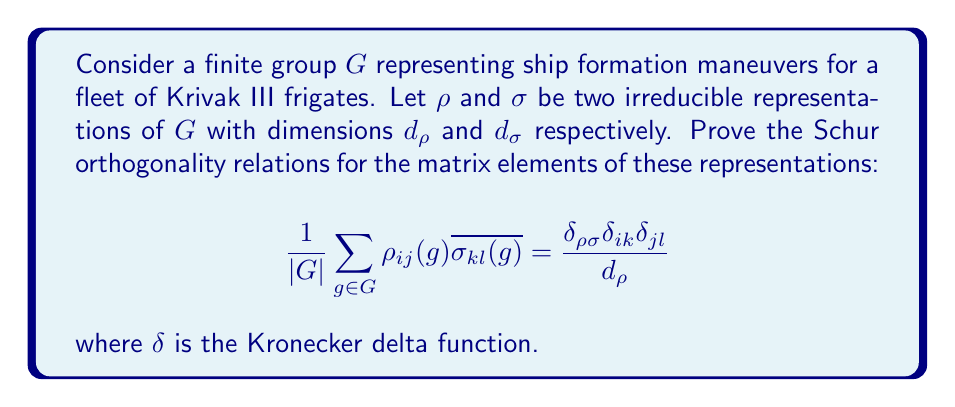Show me your answer to this math problem. To prove the Schur orthogonality relations, we'll follow these steps:

1) First, recall that for irreducible representations, Schur's lemma states that any intertwining operator between them is either zero (if the representations are inequivalent) or a scalar multiple of the identity (if they are equivalent).

2) Define the linear map $T: V_\sigma \to V_\rho$ as:

   $$T = \frac{1}{|G|} \sum_{g \in G} \rho(g) A \sigma(g^{-1})$$

   where $A$ is any linear map from $V_\sigma$ to $V_\rho$.

3) Show that $T$ is an intertwining operator:

   $$\begin{align*}
   \rho(h)T &= \frac{1}{|G|} \sum_{g \in G} \rho(h)\rho(g) A \sigma(g^{-1}) \\
   &= \frac{1}{|G|} \sum_{g \in G} \rho(hg) A \sigma(g^{-1}) \\
   &= \frac{1}{|G|} \sum_{g' \in G} \rho(g') A \sigma((h^{-1}g')^{-1}) \\
   &= \frac{1}{|G|} \sum_{g' \in G} \rho(g') A \sigma(g'^{-1})\sigma(h) \\
   &= T\sigma(h)
   \end{align*}$$

4) By Schur's lemma, $T$ must be zero if $\rho$ and $\sigma$ are inequivalent, or a scalar multiple of the identity if they are equivalent.

5) Choose $A = E_{kl}$, the matrix with 1 in the $(k,l)$ position and 0 elsewhere. Then the $(i,j)$ element of $T$ is:

   $$T_{ij} = \frac{1}{|G|} \sum_{g \in G} \rho_{ij}(g) \overline{\sigma_{kl}(g)}$$

6) If $\rho$ and $\sigma$ are inequivalent, $T = 0$, so $T_{ij} = 0$ for all $i,j$.

7) If $\rho = \sigma$, then $T = cI$ for some scalar $c$. Taking the trace of both sides:

   $$\text{tr}(T) = \frac{1}{|G|} \sum_{g \in G} \text{tr}(\rho(g)E_{kl}) = c d_\rho$$

   The left side simplifies to $\frac{1}{|G|} \sum_{g \in G} \rho_{lk}(g) = \delta_{lk}$

   Therefore, $c = \frac{\delta_{lk}}{d_\rho}$

8) Combining these results gives us the Schur orthogonality relations:

   $$\frac{1}{|G|} \sum_{g \in G} \rho_{ij}(g) \overline{\sigma_{kl}(g)} = \frac{\delta_{\rho\sigma} \delta_{ik} \delta_{jl}}{d_\rho}$$
Answer: $$\frac{1}{|G|} \sum_{g \in G} \rho_{ij}(g) \overline{\sigma_{kl}(g)} = \frac{\delta_{\rho\sigma} \delta_{ik} \delta_{jl}}{d_\rho}$$ 